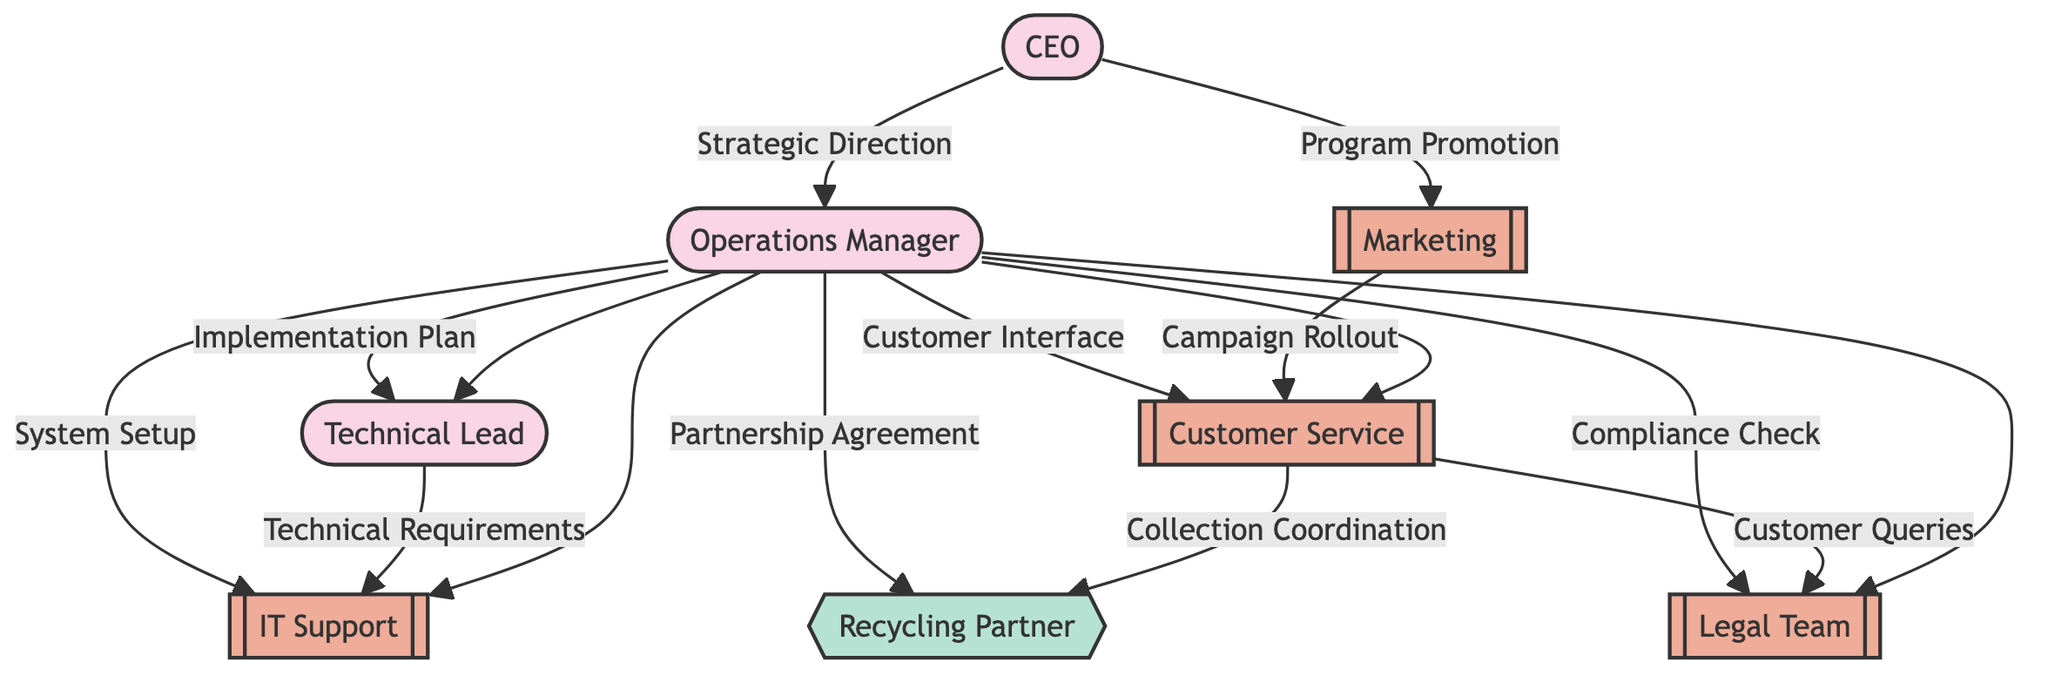What is the total number of nodes in the diagram? The diagram includes eight nodes: CEO, Operations Manager, Technical Lead, Customer Service, Marketing, Recycling Partner, IT Support, and Legal Team. Counting all the distinct entities gives a total of eight nodes.
Answer: 8 Who is responsible for the Customer Interface according to the diagram? The diagram shows an edge directed from Operations Manager to Customer Service, indicating that the Operations Manager is responsible for the Customer Interface.
Answer: Operations Manager How many edges are connected to the OpsManager node? Looking at the connections from OpsManager, there are five edges coming out: to TechLead, CustomerService, RecyclingPartner, ITSupport, and LegalTeam. Therefore, OpsManager has five outgoing edges.
Answer: 5 Which department is involved in the Campaign Rollout? The edge from Marketing to Customer Service signifies that Marketing is responsible for the Campaign Rollout.
Answer: Marketing What is the relationship between Customer Service and Recycling Partner? The diagram shows a directed edge from Customer Service to Recycling Partner labeled "Collection Coordination," indicating that there is a relationship where Customer Service coordinates the collection with the Recycling Partner.
Answer: Collection Coordination What is the main communication flow starting from the CEO? The CEO has two main communication flows: one to OpsManager for Strategic Direction and another to Marketing for Program Promotion. The first is critical for implementation, while the second focuses on communication.
Answer: OpsManager, Marketing What is the primary role of the Tech Lead as illustrated in the diagram? The Tech Lead receives the Implementation Plan from OpsManager and is also tasked with conveying Technical Requirements to IT Support, showing that the Tech Lead plays a vital role in technical execution.
Answer: Implementation Plan, Technical Requirements How many connections lead to Legal Team? Legal Team has two incoming edges — one from OpsManager for Compliance Check and another from Customer Service for Customer Queries, indicating an important role in compliance and customer support.
Answer: 2 Which node represents an external entity? In the diagram, the Recycling Partner is the only node labeled as an external entity, depicted with a different style to signify its external relationship in the program implementation.
Answer: Recycling Partner 